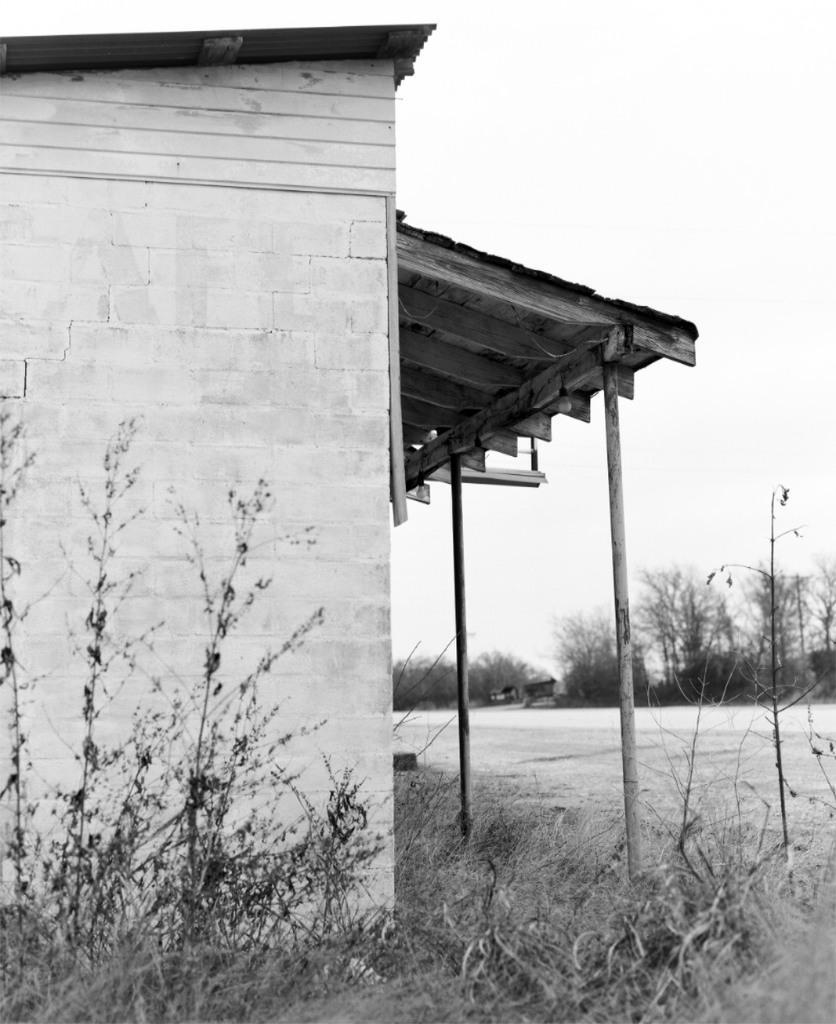Describe this image in one or two sentences. In the picture I can see a roofing sheet house and there are few plants beside it and there are few other plants in the background. 